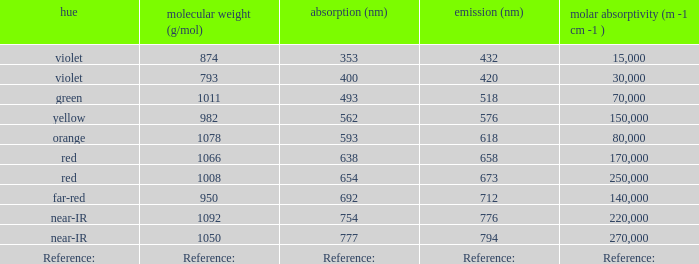What is the Absorbtion (in nanometers) of the color Violet with an emission of 432 nm? 353.0. 